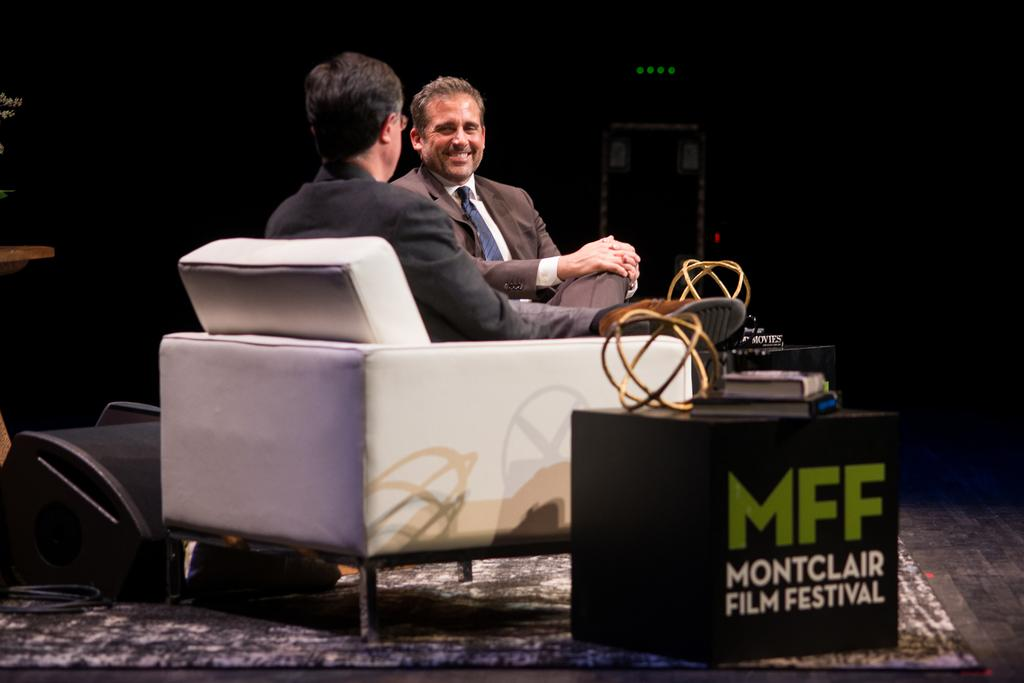How many people are sitting on the couch in the image? There are two persons sitting on the couch in the image. What color is the couch? The couch is white. What is located in front of the couch? There is a table in front of the couch. What can be found on the table? There are books on the table. Can you see a hen sitting on the table in the image? No, there is no hen present in the image. What type of badge is being worn by one of the persons sitting on the couch? There is no badge visible on either person in the image. 